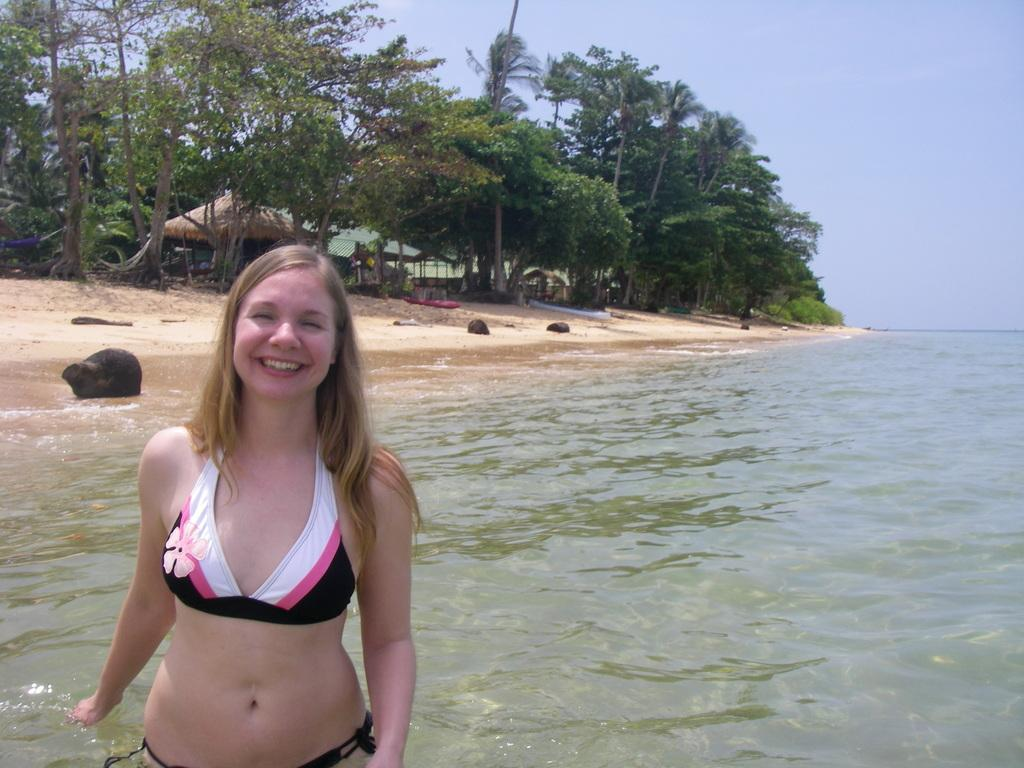What is the woman in the image doing? The woman is standing in the water. What type of animals can be seen in the image? There are harms visible in the image. What type of vegetation is present in the image? There are trees in the image. What is the color of the object in the image? There is an object that is black in color in the image. How does the woman describe her experience at the seashore in the image? There is no mention of a seashore in the image, and the woman's experience cannot be determined from the image alone. 